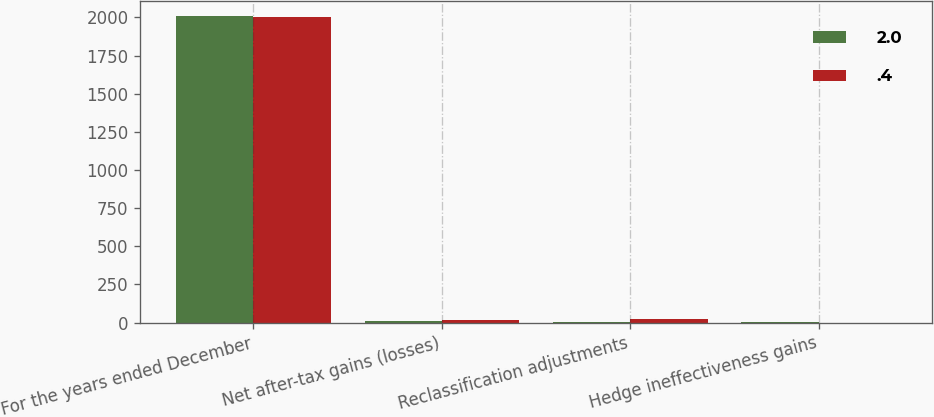<chart> <loc_0><loc_0><loc_500><loc_500><stacked_bar_chart><ecel><fcel>For the years ended December<fcel>Net after-tax gains (losses)<fcel>Reclassification adjustments<fcel>Hedge ineffectiveness gains<nl><fcel>2<fcel>2006<fcel>11.4<fcel>5.3<fcel>2<nl><fcel>0.4<fcel>2004<fcel>16.3<fcel>26.1<fcel>0.4<nl></chart> 